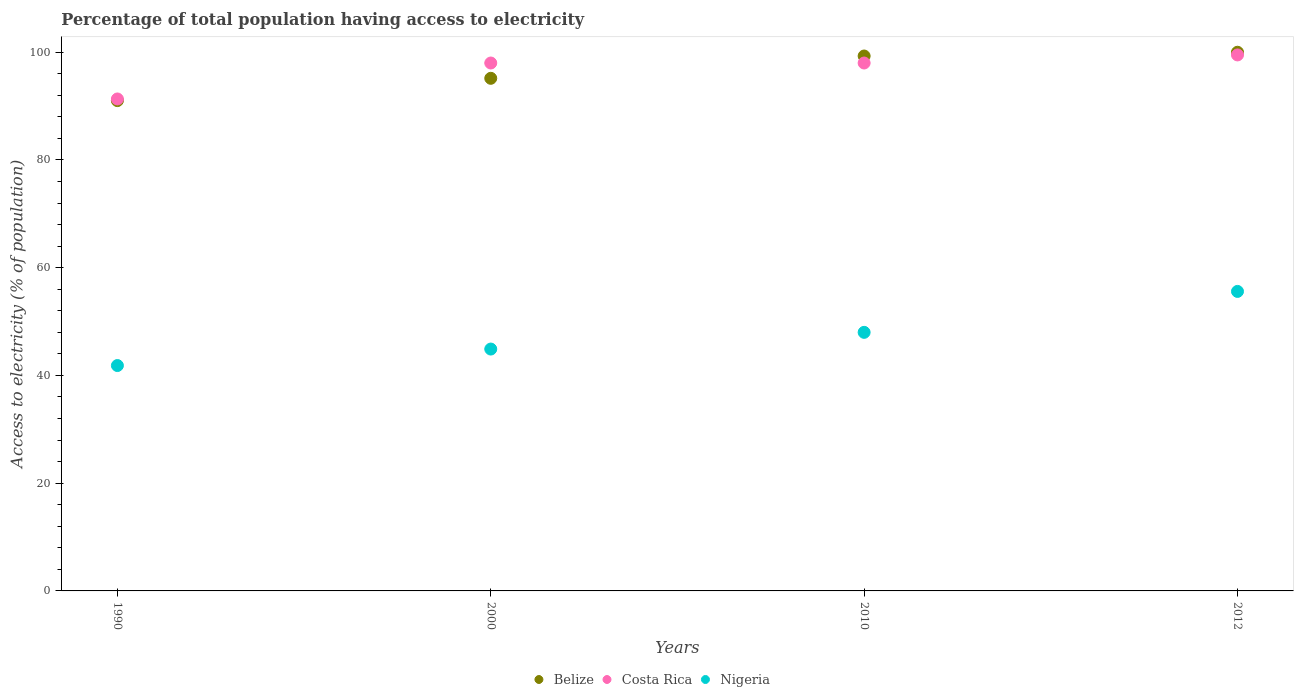Is the number of dotlines equal to the number of legend labels?
Provide a short and direct response. Yes. What is the percentage of population that have access to electricity in Belize in 1990?
Provide a succinct answer. 91.02. Across all years, what is the maximum percentage of population that have access to electricity in Nigeria?
Provide a short and direct response. 55.6. Across all years, what is the minimum percentage of population that have access to electricity in Belize?
Provide a succinct answer. 91.02. What is the total percentage of population that have access to electricity in Belize in the graph?
Offer a terse response. 385.48. What is the difference between the percentage of population that have access to electricity in Costa Rica in 2000 and the percentage of population that have access to electricity in Belize in 2010?
Make the answer very short. -1.3. What is the average percentage of population that have access to electricity in Costa Rica per year?
Ensure brevity in your answer.  96.71. In the year 1990, what is the difference between the percentage of population that have access to electricity in Nigeria and percentage of population that have access to electricity in Costa Rica?
Provide a succinct answer. -49.49. In how many years, is the percentage of population that have access to electricity in Nigeria greater than 8 %?
Provide a succinct answer. 4. What is the ratio of the percentage of population that have access to electricity in Nigeria in 2000 to that in 2010?
Offer a terse response. 0.94. Is the percentage of population that have access to electricity in Nigeria in 2010 less than that in 2012?
Provide a short and direct response. Yes. What is the difference between the highest and the second highest percentage of population that have access to electricity in Belize?
Offer a terse response. 0.7. What is the difference between the highest and the lowest percentage of population that have access to electricity in Nigeria?
Offer a very short reply. 13.76. Is it the case that in every year, the sum of the percentage of population that have access to electricity in Nigeria and percentage of population that have access to electricity in Belize  is greater than the percentage of population that have access to electricity in Costa Rica?
Your answer should be compact. Yes. Is the percentage of population that have access to electricity in Costa Rica strictly greater than the percentage of population that have access to electricity in Nigeria over the years?
Keep it short and to the point. Yes. What is the difference between two consecutive major ticks on the Y-axis?
Keep it short and to the point. 20. Are the values on the major ticks of Y-axis written in scientific E-notation?
Provide a short and direct response. No. Does the graph contain any zero values?
Your answer should be compact. No. Does the graph contain grids?
Provide a succinct answer. No. Where does the legend appear in the graph?
Give a very brief answer. Bottom center. How many legend labels are there?
Provide a succinct answer. 3. What is the title of the graph?
Provide a succinct answer. Percentage of total population having access to electricity. Does "Iraq" appear as one of the legend labels in the graph?
Keep it short and to the point. No. What is the label or title of the X-axis?
Give a very brief answer. Years. What is the label or title of the Y-axis?
Ensure brevity in your answer.  Access to electricity (% of population). What is the Access to electricity (% of population) in Belize in 1990?
Offer a very short reply. 91.02. What is the Access to electricity (% of population) in Costa Rica in 1990?
Your answer should be very brief. 91.33. What is the Access to electricity (% of population) of Nigeria in 1990?
Your answer should be compact. 41.84. What is the Access to electricity (% of population) in Belize in 2000?
Provide a short and direct response. 95.16. What is the Access to electricity (% of population) in Nigeria in 2000?
Keep it short and to the point. 44.9. What is the Access to electricity (% of population) of Belize in 2010?
Provide a short and direct response. 99.3. What is the Access to electricity (% of population) in Costa Rica in 2010?
Offer a terse response. 98. What is the Access to electricity (% of population) of Costa Rica in 2012?
Offer a terse response. 99.5. What is the Access to electricity (% of population) in Nigeria in 2012?
Ensure brevity in your answer.  55.6. Across all years, what is the maximum Access to electricity (% of population) in Costa Rica?
Your response must be concise. 99.5. Across all years, what is the maximum Access to electricity (% of population) in Nigeria?
Your answer should be compact. 55.6. Across all years, what is the minimum Access to electricity (% of population) in Belize?
Offer a very short reply. 91.02. Across all years, what is the minimum Access to electricity (% of population) in Costa Rica?
Give a very brief answer. 91.33. Across all years, what is the minimum Access to electricity (% of population) in Nigeria?
Provide a short and direct response. 41.84. What is the total Access to electricity (% of population) of Belize in the graph?
Offer a terse response. 385.48. What is the total Access to electricity (% of population) in Costa Rica in the graph?
Give a very brief answer. 386.83. What is the total Access to electricity (% of population) of Nigeria in the graph?
Your answer should be compact. 190.34. What is the difference between the Access to electricity (% of population) in Belize in 1990 and that in 2000?
Offer a very short reply. -4.14. What is the difference between the Access to electricity (% of population) of Costa Rica in 1990 and that in 2000?
Your response must be concise. -6.67. What is the difference between the Access to electricity (% of population) in Nigeria in 1990 and that in 2000?
Offer a terse response. -3.06. What is the difference between the Access to electricity (% of population) in Belize in 1990 and that in 2010?
Your response must be concise. -8.28. What is the difference between the Access to electricity (% of population) in Costa Rica in 1990 and that in 2010?
Provide a succinct answer. -6.67. What is the difference between the Access to electricity (% of population) of Nigeria in 1990 and that in 2010?
Ensure brevity in your answer.  -6.16. What is the difference between the Access to electricity (% of population) in Belize in 1990 and that in 2012?
Provide a short and direct response. -8.98. What is the difference between the Access to electricity (% of population) in Costa Rica in 1990 and that in 2012?
Provide a succinct answer. -8.17. What is the difference between the Access to electricity (% of population) of Nigeria in 1990 and that in 2012?
Provide a succinct answer. -13.76. What is the difference between the Access to electricity (% of population) of Belize in 2000 and that in 2010?
Your response must be concise. -4.14. What is the difference between the Access to electricity (% of population) in Belize in 2000 and that in 2012?
Offer a terse response. -4.84. What is the difference between the Access to electricity (% of population) in Costa Rica in 2000 and that in 2012?
Your response must be concise. -1.5. What is the difference between the Access to electricity (% of population) of Nigeria in 2000 and that in 2012?
Give a very brief answer. -10.7. What is the difference between the Access to electricity (% of population) of Belize in 2010 and that in 2012?
Provide a short and direct response. -0.7. What is the difference between the Access to electricity (% of population) in Belize in 1990 and the Access to electricity (% of population) in Costa Rica in 2000?
Offer a terse response. -6.98. What is the difference between the Access to electricity (% of population) in Belize in 1990 and the Access to electricity (% of population) in Nigeria in 2000?
Provide a short and direct response. 46.12. What is the difference between the Access to electricity (% of population) of Costa Rica in 1990 and the Access to electricity (% of population) of Nigeria in 2000?
Keep it short and to the point. 46.43. What is the difference between the Access to electricity (% of population) in Belize in 1990 and the Access to electricity (% of population) in Costa Rica in 2010?
Keep it short and to the point. -6.98. What is the difference between the Access to electricity (% of population) of Belize in 1990 and the Access to electricity (% of population) of Nigeria in 2010?
Offer a terse response. 43.02. What is the difference between the Access to electricity (% of population) in Costa Rica in 1990 and the Access to electricity (% of population) in Nigeria in 2010?
Keep it short and to the point. 43.33. What is the difference between the Access to electricity (% of population) of Belize in 1990 and the Access to electricity (% of population) of Costa Rica in 2012?
Provide a succinct answer. -8.48. What is the difference between the Access to electricity (% of population) in Belize in 1990 and the Access to electricity (% of population) in Nigeria in 2012?
Your answer should be compact. 35.42. What is the difference between the Access to electricity (% of population) of Costa Rica in 1990 and the Access to electricity (% of population) of Nigeria in 2012?
Provide a succinct answer. 35.73. What is the difference between the Access to electricity (% of population) of Belize in 2000 and the Access to electricity (% of population) of Costa Rica in 2010?
Your response must be concise. -2.84. What is the difference between the Access to electricity (% of population) in Belize in 2000 and the Access to electricity (% of population) in Nigeria in 2010?
Make the answer very short. 47.16. What is the difference between the Access to electricity (% of population) in Costa Rica in 2000 and the Access to electricity (% of population) in Nigeria in 2010?
Offer a terse response. 50. What is the difference between the Access to electricity (% of population) in Belize in 2000 and the Access to electricity (% of population) in Costa Rica in 2012?
Your answer should be compact. -4.34. What is the difference between the Access to electricity (% of population) in Belize in 2000 and the Access to electricity (% of population) in Nigeria in 2012?
Provide a short and direct response. 39.56. What is the difference between the Access to electricity (% of population) in Costa Rica in 2000 and the Access to electricity (% of population) in Nigeria in 2012?
Keep it short and to the point. 42.4. What is the difference between the Access to electricity (% of population) in Belize in 2010 and the Access to electricity (% of population) in Costa Rica in 2012?
Keep it short and to the point. -0.2. What is the difference between the Access to electricity (% of population) in Belize in 2010 and the Access to electricity (% of population) in Nigeria in 2012?
Your answer should be very brief. 43.7. What is the difference between the Access to electricity (% of population) of Costa Rica in 2010 and the Access to electricity (% of population) of Nigeria in 2012?
Offer a terse response. 42.4. What is the average Access to electricity (% of population) of Belize per year?
Your answer should be very brief. 96.37. What is the average Access to electricity (% of population) of Costa Rica per year?
Provide a succinct answer. 96.71. What is the average Access to electricity (% of population) of Nigeria per year?
Your answer should be very brief. 47.58. In the year 1990, what is the difference between the Access to electricity (% of population) of Belize and Access to electricity (% of population) of Costa Rica?
Ensure brevity in your answer.  -0.3. In the year 1990, what is the difference between the Access to electricity (% of population) of Belize and Access to electricity (% of population) of Nigeria?
Provide a succinct answer. 49.18. In the year 1990, what is the difference between the Access to electricity (% of population) of Costa Rica and Access to electricity (% of population) of Nigeria?
Provide a short and direct response. 49.49. In the year 2000, what is the difference between the Access to electricity (% of population) in Belize and Access to electricity (% of population) in Costa Rica?
Provide a short and direct response. -2.84. In the year 2000, what is the difference between the Access to electricity (% of population) of Belize and Access to electricity (% of population) of Nigeria?
Your answer should be compact. 50.26. In the year 2000, what is the difference between the Access to electricity (% of population) of Costa Rica and Access to electricity (% of population) of Nigeria?
Give a very brief answer. 53.1. In the year 2010, what is the difference between the Access to electricity (% of population) of Belize and Access to electricity (% of population) of Nigeria?
Make the answer very short. 51.3. In the year 2010, what is the difference between the Access to electricity (% of population) of Costa Rica and Access to electricity (% of population) of Nigeria?
Offer a very short reply. 50. In the year 2012, what is the difference between the Access to electricity (% of population) of Belize and Access to electricity (% of population) of Nigeria?
Keep it short and to the point. 44.4. In the year 2012, what is the difference between the Access to electricity (% of population) of Costa Rica and Access to electricity (% of population) of Nigeria?
Offer a very short reply. 43.9. What is the ratio of the Access to electricity (% of population) of Belize in 1990 to that in 2000?
Ensure brevity in your answer.  0.96. What is the ratio of the Access to electricity (% of population) of Costa Rica in 1990 to that in 2000?
Ensure brevity in your answer.  0.93. What is the ratio of the Access to electricity (% of population) in Nigeria in 1990 to that in 2000?
Your answer should be very brief. 0.93. What is the ratio of the Access to electricity (% of population) of Belize in 1990 to that in 2010?
Offer a very short reply. 0.92. What is the ratio of the Access to electricity (% of population) of Costa Rica in 1990 to that in 2010?
Ensure brevity in your answer.  0.93. What is the ratio of the Access to electricity (% of population) of Nigeria in 1990 to that in 2010?
Your answer should be very brief. 0.87. What is the ratio of the Access to electricity (% of population) in Belize in 1990 to that in 2012?
Give a very brief answer. 0.91. What is the ratio of the Access to electricity (% of population) in Costa Rica in 1990 to that in 2012?
Give a very brief answer. 0.92. What is the ratio of the Access to electricity (% of population) in Nigeria in 1990 to that in 2012?
Keep it short and to the point. 0.75. What is the ratio of the Access to electricity (% of population) of Belize in 2000 to that in 2010?
Offer a terse response. 0.96. What is the ratio of the Access to electricity (% of population) in Nigeria in 2000 to that in 2010?
Ensure brevity in your answer.  0.94. What is the ratio of the Access to electricity (% of population) of Belize in 2000 to that in 2012?
Provide a succinct answer. 0.95. What is the ratio of the Access to electricity (% of population) of Costa Rica in 2000 to that in 2012?
Provide a succinct answer. 0.98. What is the ratio of the Access to electricity (% of population) in Nigeria in 2000 to that in 2012?
Your answer should be compact. 0.81. What is the ratio of the Access to electricity (% of population) of Belize in 2010 to that in 2012?
Offer a very short reply. 0.99. What is the ratio of the Access to electricity (% of population) in Costa Rica in 2010 to that in 2012?
Give a very brief answer. 0.98. What is the ratio of the Access to electricity (% of population) in Nigeria in 2010 to that in 2012?
Provide a short and direct response. 0.86. What is the difference between the highest and the second highest Access to electricity (% of population) of Costa Rica?
Make the answer very short. 1.5. What is the difference between the highest and the second highest Access to electricity (% of population) in Nigeria?
Provide a short and direct response. 7.6. What is the difference between the highest and the lowest Access to electricity (% of population) of Belize?
Make the answer very short. 8.98. What is the difference between the highest and the lowest Access to electricity (% of population) of Costa Rica?
Provide a short and direct response. 8.17. What is the difference between the highest and the lowest Access to electricity (% of population) of Nigeria?
Keep it short and to the point. 13.76. 